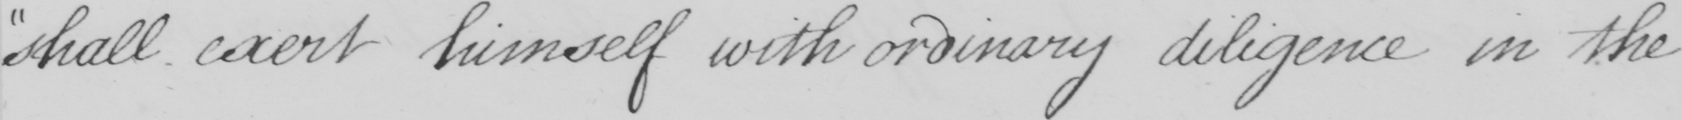What is written in this line of handwriting? shall exert himself with ordinary diligence in the 